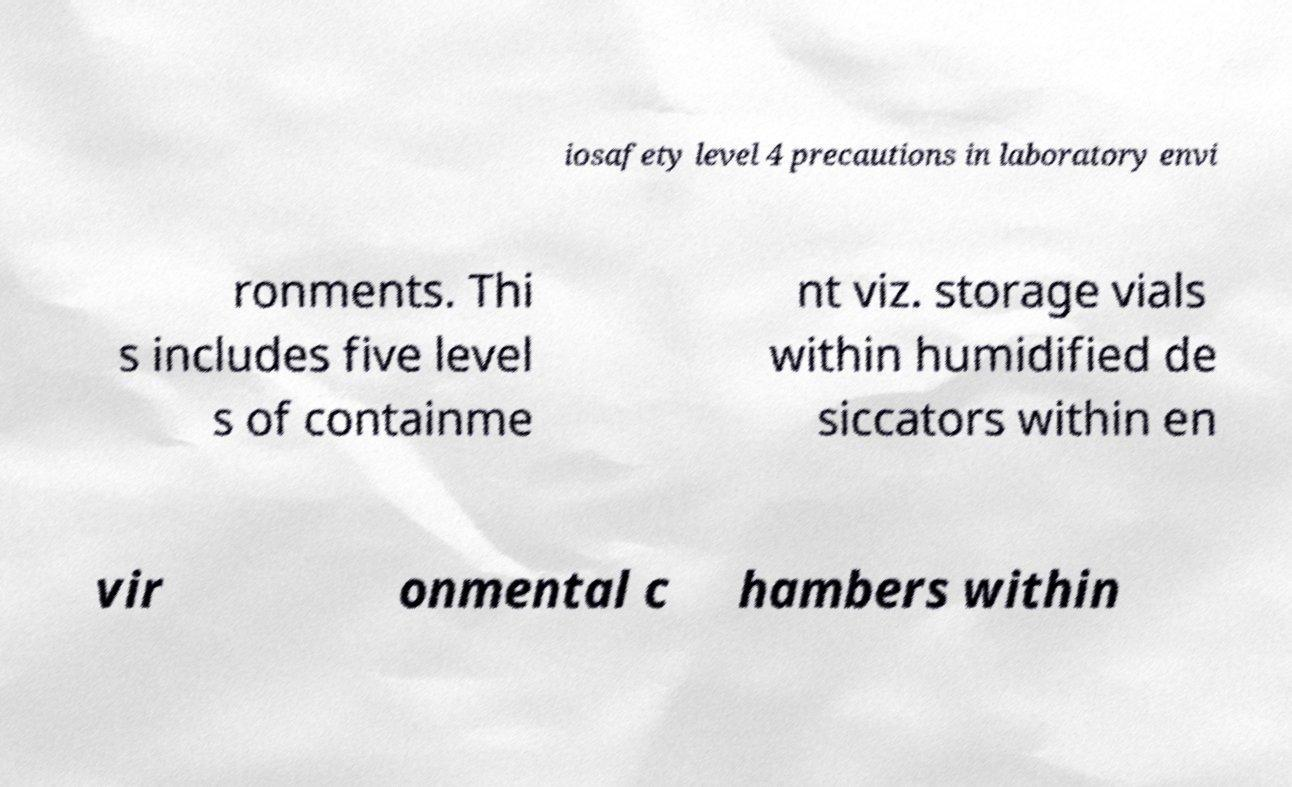For documentation purposes, I need the text within this image transcribed. Could you provide that? iosafety level 4 precautions in laboratory envi ronments. Thi s includes five level s of containme nt viz. storage vials within humidified de siccators within en vir onmental c hambers within 